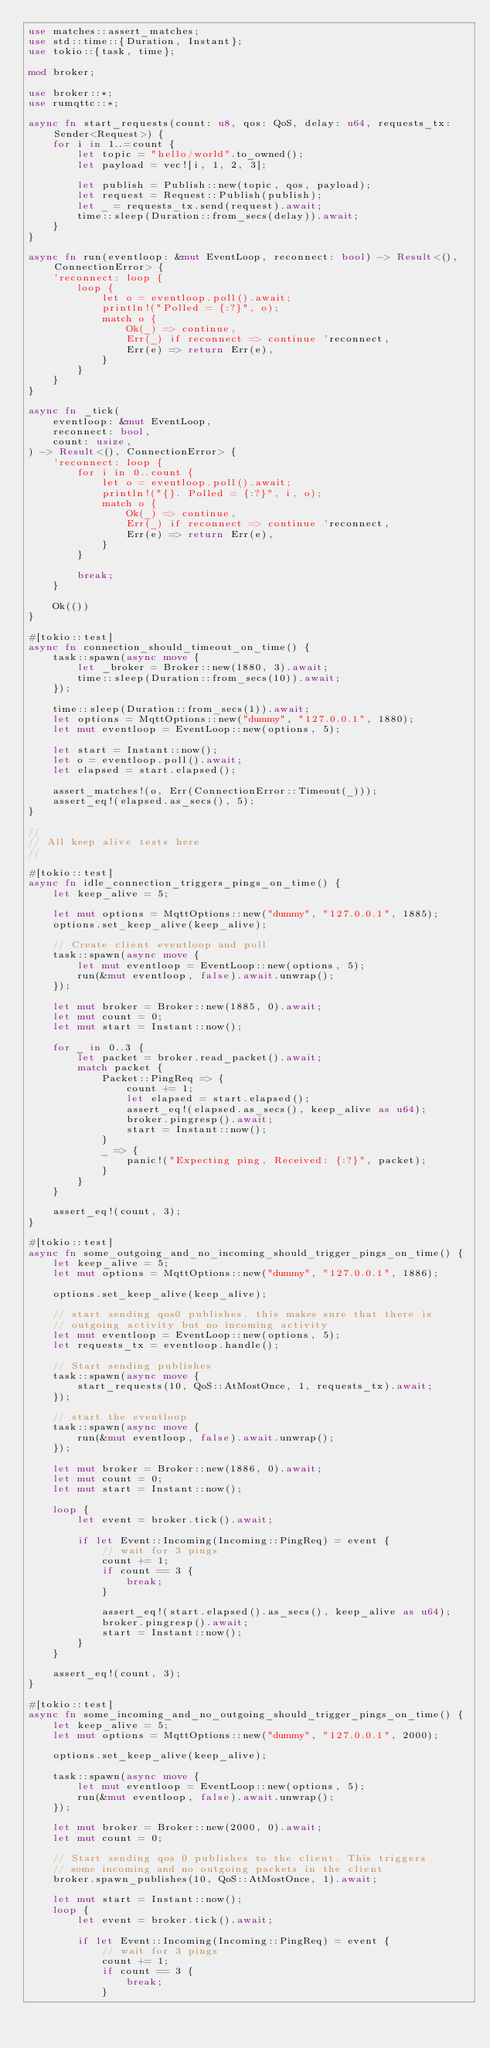<code> <loc_0><loc_0><loc_500><loc_500><_Rust_>use matches::assert_matches;
use std::time::{Duration, Instant};
use tokio::{task, time};

mod broker;

use broker::*;
use rumqttc::*;

async fn start_requests(count: u8, qos: QoS, delay: u64, requests_tx: Sender<Request>) {
    for i in 1..=count {
        let topic = "hello/world".to_owned();
        let payload = vec![i, 1, 2, 3];

        let publish = Publish::new(topic, qos, payload);
        let request = Request::Publish(publish);
        let _ = requests_tx.send(request).await;
        time::sleep(Duration::from_secs(delay)).await;
    }
}

async fn run(eventloop: &mut EventLoop, reconnect: bool) -> Result<(), ConnectionError> {
    'reconnect: loop {
        loop {
            let o = eventloop.poll().await;
            println!("Polled = {:?}", o);
            match o {
                Ok(_) => continue,
                Err(_) if reconnect => continue 'reconnect,
                Err(e) => return Err(e),
            }
        }
    }
}

async fn _tick(
    eventloop: &mut EventLoop,
    reconnect: bool,
    count: usize,
) -> Result<(), ConnectionError> {
    'reconnect: loop {
        for i in 0..count {
            let o = eventloop.poll().await;
            println!("{}. Polled = {:?}", i, o);
            match o {
                Ok(_) => continue,
                Err(_) if reconnect => continue 'reconnect,
                Err(e) => return Err(e),
            }
        }

        break;
    }

    Ok(())
}

#[tokio::test]
async fn connection_should_timeout_on_time() {
    task::spawn(async move {
        let _broker = Broker::new(1880, 3).await;
        time::sleep(Duration::from_secs(10)).await;
    });

    time::sleep(Duration::from_secs(1)).await;
    let options = MqttOptions::new("dummy", "127.0.0.1", 1880);
    let mut eventloop = EventLoop::new(options, 5);

    let start = Instant::now();
    let o = eventloop.poll().await;
    let elapsed = start.elapsed();

    assert_matches!(o, Err(ConnectionError::Timeout(_)));
    assert_eq!(elapsed.as_secs(), 5);
}

//
// All keep alive tests here
//

#[tokio::test]
async fn idle_connection_triggers_pings_on_time() {
    let keep_alive = 5;

    let mut options = MqttOptions::new("dummy", "127.0.0.1", 1885);
    options.set_keep_alive(keep_alive);

    // Create client eventloop and poll
    task::spawn(async move {
        let mut eventloop = EventLoop::new(options, 5);
        run(&mut eventloop, false).await.unwrap();
    });

    let mut broker = Broker::new(1885, 0).await;
    let mut count = 0;
    let mut start = Instant::now();

    for _ in 0..3 {
        let packet = broker.read_packet().await;
        match packet {
            Packet::PingReq => {
                count += 1;
                let elapsed = start.elapsed();
                assert_eq!(elapsed.as_secs(), keep_alive as u64);
                broker.pingresp().await;
                start = Instant::now();
            }
            _ => {
                panic!("Expecting ping, Received: {:?}", packet);
            }
        }
    }

    assert_eq!(count, 3);
}

#[tokio::test]
async fn some_outgoing_and_no_incoming_should_trigger_pings_on_time() {
    let keep_alive = 5;
    let mut options = MqttOptions::new("dummy", "127.0.0.1", 1886);

    options.set_keep_alive(keep_alive);

    // start sending qos0 publishes. this makes sure that there is
    // outgoing activity but no incoming activity
    let mut eventloop = EventLoop::new(options, 5);
    let requests_tx = eventloop.handle();

    // Start sending publishes
    task::spawn(async move {
        start_requests(10, QoS::AtMostOnce, 1, requests_tx).await;
    });

    // start the eventloop
    task::spawn(async move {
        run(&mut eventloop, false).await.unwrap();
    });

    let mut broker = Broker::new(1886, 0).await;
    let mut count = 0;
    let mut start = Instant::now();

    loop {
        let event = broker.tick().await;

        if let Event::Incoming(Incoming::PingReq) = event {
            // wait for 3 pings
            count += 1;
            if count == 3 {
                break;
            }

            assert_eq!(start.elapsed().as_secs(), keep_alive as u64);
            broker.pingresp().await;
            start = Instant::now();
        }
    }

    assert_eq!(count, 3);
}

#[tokio::test]
async fn some_incoming_and_no_outgoing_should_trigger_pings_on_time() {
    let keep_alive = 5;
    let mut options = MqttOptions::new("dummy", "127.0.0.1", 2000);

    options.set_keep_alive(keep_alive);

    task::spawn(async move {
        let mut eventloop = EventLoop::new(options, 5);
        run(&mut eventloop, false).await.unwrap();
    });

    let mut broker = Broker::new(2000, 0).await;
    let mut count = 0;

    // Start sending qos 0 publishes to the client. This triggers
    // some incoming and no outgoing packets in the client
    broker.spawn_publishes(10, QoS::AtMostOnce, 1).await;

    let mut start = Instant::now();
    loop {
        let event = broker.tick().await;

        if let Event::Incoming(Incoming::PingReq) = event {
            // wait for 3 pings
            count += 1;
            if count == 3 {
                break;
            }
</code> 